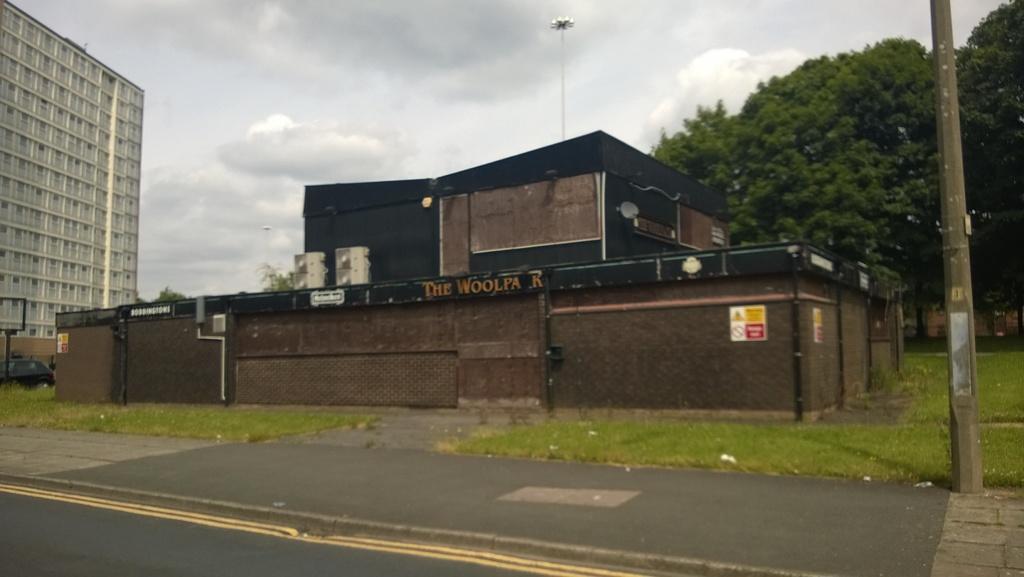In one or two sentences, can you explain what this image depicts? In this image in the center there is one house, on the left side there is one building, car and pole on the right side there is a pole and some trees. And in the center there is one pole and some lights, in the foreground there is grass and road. On the top of the image there is sky. 